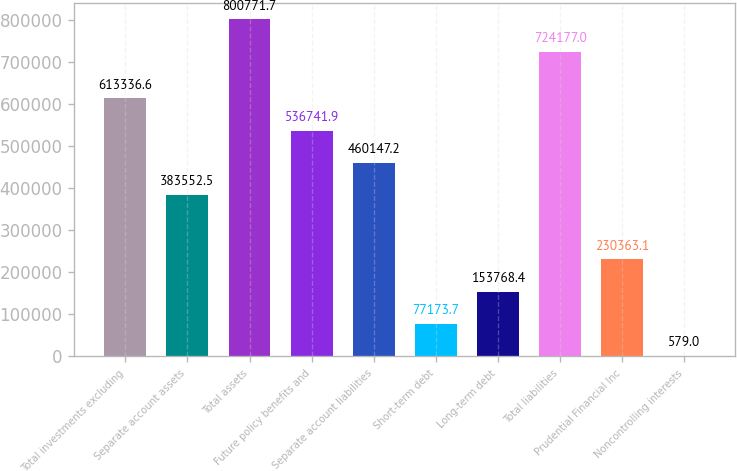Convert chart to OTSL. <chart><loc_0><loc_0><loc_500><loc_500><bar_chart><fcel>Total investments excluding<fcel>Separate account assets<fcel>Total assets<fcel>Future policy benefits and<fcel>Separate account liabilities<fcel>Short-term debt<fcel>Long-term debt<fcel>Total liabilities<fcel>Prudential Financial Inc<fcel>Noncontrolling interests<nl><fcel>613337<fcel>383552<fcel>800772<fcel>536742<fcel>460147<fcel>77173.7<fcel>153768<fcel>724177<fcel>230363<fcel>579<nl></chart> 